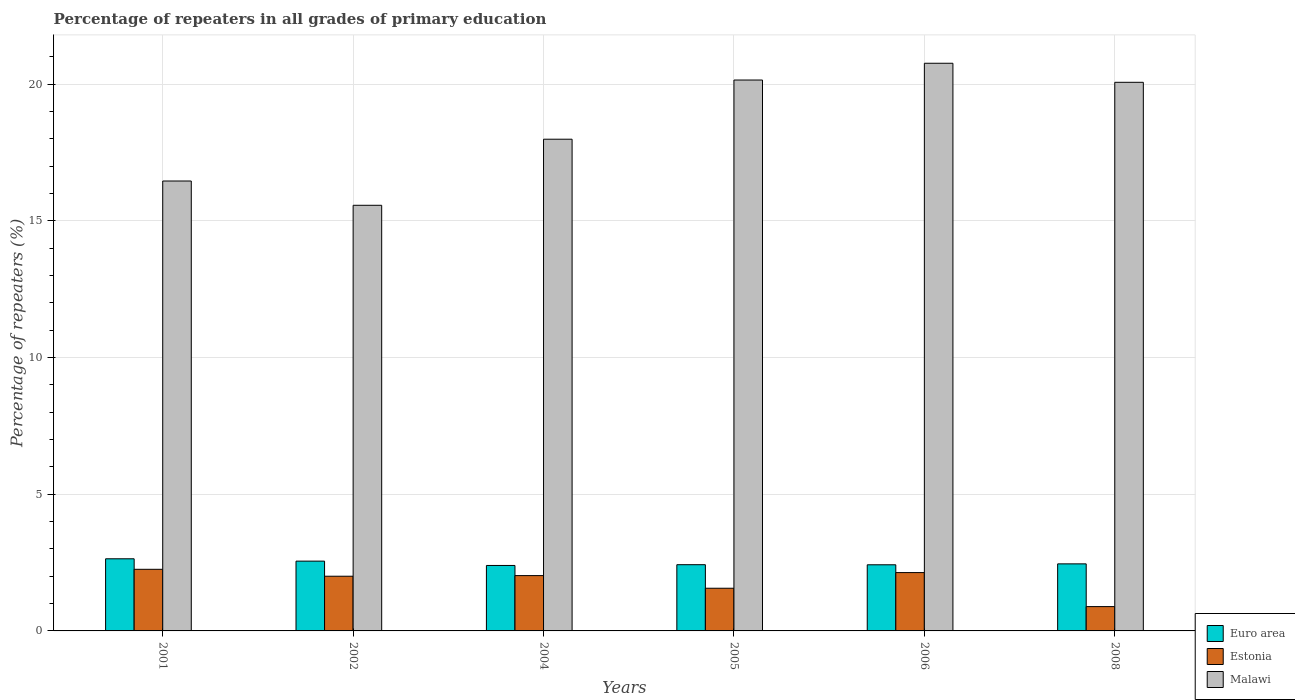How many different coloured bars are there?
Offer a terse response. 3. How many groups of bars are there?
Your answer should be compact. 6. Are the number of bars per tick equal to the number of legend labels?
Provide a succinct answer. Yes. Are the number of bars on each tick of the X-axis equal?
Your answer should be compact. Yes. How many bars are there on the 6th tick from the right?
Offer a very short reply. 3. What is the label of the 6th group of bars from the left?
Make the answer very short. 2008. What is the percentage of repeaters in Estonia in 2008?
Keep it short and to the point. 0.89. Across all years, what is the maximum percentage of repeaters in Estonia?
Your response must be concise. 2.25. Across all years, what is the minimum percentage of repeaters in Euro area?
Provide a short and direct response. 2.39. In which year was the percentage of repeaters in Estonia maximum?
Your answer should be very brief. 2001. What is the total percentage of repeaters in Malawi in the graph?
Provide a short and direct response. 111.03. What is the difference between the percentage of repeaters in Euro area in 2001 and that in 2008?
Offer a very short reply. 0.19. What is the difference between the percentage of repeaters in Estonia in 2008 and the percentage of repeaters in Euro area in 2004?
Ensure brevity in your answer.  -1.51. What is the average percentage of repeaters in Malawi per year?
Ensure brevity in your answer.  18.5. In the year 2002, what is the difference between the percentage of repeaters in Euro area and percentage of repeaters in Estonia?
Your answer should be very brief. 0.55. In how many years, is the percentage of repeaters in Estonia greater than 11 %?
Offer a terse response. 0. What is the ratio of the percentage of repeaters in Estonia in 2001 to that in 2006?
Give a very brief answer. 1.06. Is the percentage of repeaters in Malawi in 2001 less than that in 2004?
Provide a short and direct response. Yes. What is the difference between the highest and the second highest percentage of repeaters in Euro area?
Your answer should be very brief. 0.09. What is the difference between the highest and the lowest percentage of repeaters in Estonia?
Your answer should be compact. 1.36. In how many years, is the percentage of repeaters in Estonia greater than the average percentage of repeaters in Estonia taken over all years?
Provide a short and direct response. 4. Is the sum of the percentage of repeaters in Euro area in 2001 and 2005 greater than the maximum percentage of repeaters in Estonia across all years?
Your answer should be very brief. Yes. What does the 3rd bar from the left in 2006 represents?
Your answer should be very brief. Malawi. What does the 2nd bar from the right in 2008 represents?
Provide a short and direct response. Estonia. What is the difference between two consecutive major ticks on the Y-axis?
Your response must be concise. 5. How many legend labels are there?
Ensure brevity in your answer.  3. How are the legend labels stacked?
Your answer should be very brief. Vertical. What is the title of the graph?
Give a very brief answer. Percentage of repeaters in all grades of primary education. Does "Kazakhstan" appear as one of the legend labels in the graph?
Ensure brevity in your answer.  No. What is the label or title of the X-axis?
Provide a succinct answer. Years. What is the label or title of the Y-axis?
Offer a terse response. Percentage of repeaters (%). What is the Percentage of repeaters (%) in Euro area in 2001?
Make the answer very short. 2.64. What is the Percentage of repeaters (%) of Estonia in 2001?
Ensure brevity in your answer.  2.25. What is the Percentage of repeaters (%) in Malawi in 2001?
Provide a succinct answer. 16.46. What is the Percentage of repeaters (%) of Euro area in 2002?
Keep it short and to the point. 2.55. What is the Percentage of repeaters (%) in Estonia in 2002?
Make the answer very short. 2. What is the Percentage of repeaters (%) in Malawi in 2002?
Ensure brevity in your answer.  15.57. What is the Percentage of repeaters (%) in Euro area in 2004?
Provide a succinct answer. 2.39. What is the Percentage of repeaters (%) of Estonia in 2004?
Make the answer very short. 2.02. What is the Percentage of repeaters (%) in Malawi in 2004?
Provide a succinct answer. 17.99. What is the Percentage of repeaters (%) in Euro area in 2005?
Offer a very short reply. 2.42. What is the Percentage of repeaters (%) of Estonia in 2005?
Your answer should be very brief. 1.56. What is the Percentage of repeaters (%) of Malawi in 2005?
Your answer should be compact. 20.16. What is the Percentage of repeaters (%) of Euro area in 2006?
Offer a very short reply. 2.42. What is the Percentage of repeaters (%) in Estonia in 2006?
Provide a succinct answer. 2.13. What is the Percentage of repeaters (%) in Malawi in 2006?
Keep it short and to the point. 20.77. What is the Percentage of repeaters (%) in Euro area in 2008?
Your answer should be very brief. 2.45. What is the Percentage of repeaters (%) in Estonia in 2008?
Give a very brief answer. 0.89. What is the Percentage of repeaters (%) in Malawi in 2008?
Give a very brief answer. 20.07. Across all years, what is the maximum Percentage of repeaters (%) of Euro area?
Provide a short and direct response. 2.64. Across all years, what is the maximum Percentage of repeaters (%) of Estonia?
Your answer should be compact. 2.25. Across all years, what is the maximum Percentage of repeaters (%) of Malawi?
Offer a very short reply. 20.77. Across all years, what is the minimum Percentage of repeaters (%) in Euro area?
Offer a very short reply. 2.39. Across all years, what is the minimum Percentage of repeaters (%) of Estonia?
Make the answer very short. 0.89. Across all years, what is the minimum Percentage of repeaters (%) in Malawi?
Provide a succinct answer. 15.57. What is the total Percentage of repeaters (%) in Euro area in the graph?
Give a very brief answer. 14.88. What is the total Percentage of repeaters (%) in Estonia in the graph?
Give a very brief answer. 10.87. What is the total Percentage of repeaters (%) in Malawi in the graph?
Your answer should be compact. 111.03. What is the difference between the Percentage of repeaters (%) of Euro area in 2001 and that in 2002?
Offer a terse response. 0.09. What is the difference between the Percentage of repeaters (%) of Estonia in 2001 and that in 2002?
Offer a very short reply. 0.25. What is the difference between the Percentage of repeaters (%) in Malawi in 2001 and that in 2002?
Your answer should be very brief. 0.89. What is the difference between the Percentage of repeaters (%) in Euro area in 2001 and that in 2004?
Your answer should be compact. 0.24. What is the difference between the Percentage of repeaters (%) of Estonia in 2001 and that in 2004?
Offer a terse response. 0.23. What is the difference between the Percentage of repeaters (%) of Malawi in 2001 and that in 2004?
Offer a terse response. -1.53. What is the difference between the Percentage of repeaters (%) in Euro area in 2001 and that in 2005?
Keep it short and to the point. 0.22. What is the difference between the Percentage of repeaters (%) of Estonia in 2001 and that in 2005?
Make the answer very short. 0.69. What is the difference between the Percentage of repeaters (%) in Malawi in 2001 and that in 2005?
Your answer should be very brief. -3.69. What is the difference between the Percentage of repeaters (%) of Euro area in 2001 and that in 2006?
Ensure brevity in your answer.  0.22. What is the difference between the Percentage of repeaters (%) of Estonia in 2001 and that in 2006?
Make the answer very short. 0.12. What is the difference between the Percentage of repeaters (%) of Malawi in 2001 and that in 2006?
Provide a short and direct response. -4.31. What is the difference between the Percentage of repeaters (%) of Euro area in 2001 and that in 2008?
Your answer should be compact. 0.19. What is the difference between the Percentage of repeaters (%) in Estonia in 2001 and that in 2008?
Offer a very short reply. 1.36. What is the difference between the Percentage of repeaters (%) in Malawi in 2001 and that in 2008?
Ensure brevity in your answer.  -3.61. What is the difference between the Percentage of repeaters (%) of Euro area in 2002 and that in 2004?
Keep it short and to the point. 0.16. What is the difference between the Percentage of repeaters (%) of Estonia in 2002 and that in 2004?
Your answer should be very brief. -0.02. What is the difference between the Percentage of repeaters (%) in Malawi in 2002 and that in 2004?
Your answer should be compact. -2.42. What is the difference between the Percentage of repeaters (%) of Euro area in 2002 and that in 2005?
Offer a very short reply. 0.13. What is the difference between the Percentage of repeaters (%) of Estonia in 2002 and that in 2005?
Offer a very short reply. 0.44. What is the difference between the Percentage of repeaters (%) in Malawi in 2002 and that in 2005?
Your answer should be compact. -4.58. What is the difference between the Percentage of repeaters (%) in Euro area in 2002 and that in 2006?
Your answer should be compact. 0.13. What is the difference between the Percentage of repeaters (%) in Estonia in 2002 and that in 2006?
Make the answer very short. -0.13. What is the difference between the Percentage of repeaters (%) of Malawi in 2002 and that in 2006?
Offer a terse response. -5.2. What is the difference between the Percentage of repeaters (%) of Euro area in 2002 and that in 2008?
Offer a very short reply. 0.1. What is the difference between the Percentage of repeaters (%) in Estonia in 2002 and that in 2008?
Provide a short and direct response. 1.11. What is the difference between the Percentage of repeaters (%) of Malawi in 2002 and that in 2008?
Your response must be concise. -4.5. What is the difference between the Percentage of repeaters (%) of Euro area in 2004 and that in 2005?
Your response must be concise. -0.03. What is the difference between the Percentage of repeaters (%) of Estonia in 2004 and that in 2005?
Keep it short and to the point. 0.46. What is the difference between the Percentage of repeaters (%) of Malawi in 2004 and that in 2005?
Ensure brevity in your answer.  -2.17. What is the difference between the Percentage of repeaters (%) in Euro area in 2004 and that in 2006?
Your answer should be very brief. -0.02. What is the difference between the Percentage of repeaters (%) of Estonia in 2004 and that in 2006?
Offer a terse response. -0.11. What is the difference between the Percentage of repeaters (%) in Malawi in 2004 and that in 2006?
Your answer should be compact. -2.78. What is the difference between the Percentage of repeaters (%) of Euro area in 2004 and that in 2008?
Your response must be concise. -0.06. What is the difference between the Percentage of repeaters (%) in Estonia in 2004 and that in 2008?
Your answer should be compact. 1.13. What is the difference between the Percentage of repeaters (%) in Malawi in 2004 and that in 2008?
Offer a terse response. -2.08. What is the difference between the Percentage of repeaters (%) in Euro area in 2005 and that in 2006?
Offer a terse response. 0. What is the difference between the Percentage of repeaters (%) of Estonia in 2005 and that in 2006?
Give a very brief answer. -0.57. What is the difference between the Percentage of repeaters (%) of Malawi in 2005 and that in 2006?
Give a very brief answer. -0.61. What is the difference between the Percentage of repeaters (%) of Euro area in 2005 and that in 2008?
Provide a succinct answer. -0.03. What is the difference between the Percentage of repeaters (%) of Estonia in 2005 and that in 2008?
Your response must be concise. 0.67. What is the difference between the Percentage of repeaters (%) of Malawi in 2005 and that in 2008?
Your answer should be very brief. 0.08. What is the difference between the Percentage of repeaters (%) in Euro area in 2006 and that in 2008?
Your response must be concise. -0.03. What is the difference between the Percentage of repeaters (%) in Estonia in 2006 and that in 2008?
Provide a short and direct response. 1.25. What is the difference between the Percentage of repeaters (%) in Malawi in 2006 and that in 2008?
Make the answer very short. 0.7. What is the difference between the Percentage of repeaters (%) of Euro area in 2001 and the Percentage of repeaters (%) of Estonia in 2002?
Give a very brief answer. 0.64. What is the difference between the Percentage of repeaters (%) of Euro area in 2001 and the Percentage of repeaters (%) of Malawi in 2002?
Make the answer very short. -12.93. What is the difference between the Percentage of repeaters (%) in Estonia in 2001 and the Percentage of repeaters (%) in Malawi in 2002?
Ensure brevity in your answer.  -13.32. What is the difference between the Percentage of repeaters (%) in Euro area in 2001 and the Percentage of repeaters (%) in Estonia in 2004?
Give a very brief answer. 0.62. What is the difference between the Percentage of repeaters (%) of Euro area in 2001 and the Percentage of repeaters (%) of Malawi in 2004?
Provide a short and direct response. -15.35. What is the difference between the Percentage of repeaters (%) of Estonia in 2001 and the Percentage of repeaters (%) of Malawi in 2004?
Offer a very short reply. -15.74. What is the difference between the Percentage of repeaters (%) of Euro area in 2001 and the Percentage of repeaters (%) of Estonia in 2005?
Offer a terse response. 1.08. What is the difference between the Percentage of repeaters (%) of Euro area in 2001 and the Percentage of repeaters (%) of Malawi in 2005?
Your response must be concise. -17.52. What is the difference between the Percentage of repeaters (%) of Estonia in 2001 and the Percentage of repeaters (%) of Malawi in 2005?
Your answer should be compact. -17.9. What is the difference between the Percentage of repeaters (%) in Euro area in 2001 and the Percentage of repeaters (%) in Estonia in 2006?
Offer a terse response. 0.5. What is the difference between the Percentage of repeaters (%) of Euro area in 2001 and the Percentage of repeaters (%) of Malawi in 2006?
Your answer should be very brief. -18.13. What is the difference between the Percentage of repeaters (%) in Estonia in 2001 and the Percentage of repeaters (%) in Malawi in 2006?
Provide a succinct answer. -18.52. What is the difference between the Percentage of repeaters (%) of Euro area in 2001 and the Percentage of repeaters (%) of Estonia in 2008?
Your response must be concise. 1.75. What is the difference between the Percentage of repeaters (%) of Euro area in 2001 and the Percentage of repeaters (%) of Malawi in 2008?
Offer a very short reply. -17.43. What is the difference between the Percentage of repeaters (%) in Estonia in 2001 and the Percentage of repeaters (%) in Malawi in 2008?
Provide a short and direct response. -17.82. What is the difference between the Percentage of repeaters (%) of Euro area in 2002 and the Percentage of repeaters (%) of Estonia in 2004?
Your answer should be very brief. 0.53. What is the difference between the Percentage of repeaters (%) in Euro area in 2002 and the Percentage of repeaters (%) in Malawi in 2004?
Your answer should be very brief. -15.44. What is the difference between the Percentage of repeaters (%) in Estonia in 2002 and the Percentage of repeaters (%) in Malawi in 2004?
Ensure brevity in your answer.  -15.99. What is the difference between the Percentage of repeaters (%) in Euro area in 2002 and the Percentage of repeaters (%) in Malawi in 2005?
Your answer should be compact. -17.6. What is the difference between the Percentage of repeaters (%) of Estonia in 2002 and the Percentage of repeaters (%) of Malawi in 2005?
Offer a very short reply. -18.16. What is the difference between the Percentage of repeaters (%) of Euro area in 2002 and the Percentage of repeaters (%) of Estonia in 2006?
Provide a short and direct response. 0.42. What is the difference between the Percentage of repeaters (%) of Euro area in 2002 and the Percentage of repeaters (%) of Malawi in 2006?
Your response must be concise. -18.22. What is the difference between the Percentage of repeaters (%) in Estonia in 2002 and the Percentage of repeaters (%) in Malawi in 2006?
Your answer should be compact. -18.77. What is the difference between the Percentage of repeaters (%) of Euro area in 2002 and the Percentage of repeaters (%) of Estonia in 2008?
Your answer should be compact. 1.66. What is the difference between the Percentage of repeaters (%) in Euro area in 2002 and the Percentage of repeaters (%) in Malawi in 2008?
Offer a terse response. -17.52. What is the difference between the Percentage of repeaters (%) of Estonia in 2002 and the Percentage of repeaters (%) of Malawi in 2008?
Keep it short and to the point. -18.07. What is the difference between the Percentage of repeaters (%) of Euro area in 2004 and the Percentage of repeaters (%) of Estonia in 2005?
Make the answer very short. 0.83. What is the difference between the Percentage of repeaters (%) in Euro area in 2004 and the Percentage of repeaters (%) in Malawi in 2005?
Provide a short and direct response. -17.76. What is the difference between the Percentage of repeaters (%) in Estonia in 2004 and the Percentage of repeaters (%) in Malawi in 2005?
Give a very brief answer. -18.13. What is the difference between the Percentage of repeaters (%) in Euro area in 2004 and the Percentage of repeaters (%) in Estonia in 2006?
Keep it short and to the point. 0.26. What is the difference between the Percentage of repeaters (%) of Euro area in 2004 and the Percentage of repeaters (%) of Malawi in 2006?
Your response must be concise. -18.38. What is the difference between the Percentage of repeaters (%) in Estonia in 2004 and the Percentage of repeaters (%) in Malawi in 2006?
Your response must be concise. -18.75. What is the difference between the Percentage of repeaters (%) of Euro area in 2004 and the Percentage of repeaters (%) of Estonia in 2008?
Offer a very short reply. 1.51. What is the difference between the Percentage of repeaters (%) of Euro area in 2004 and the Percentage of repeaters (%) of Malawi in 2008?
Your answer should be compact. -17.68. What is the difference between the Percentage of repeaters (%) in Estonia in 2004 and the Percentage of repeaters (%) in Malawi in 2008?
Give a very brief answer. -18.05. What is the difference between the Percentage of repeaters (%) of Euro area in 2005 and the Percentage of repeaters (%) of Estonia in 2006?
Make the answer very short. 0.29. What is the difference between the Percentage of repeaters (%) in Euro area in 2005 and the Percentage of repeaters (%) in Malawi in 2006?
Provide a succinct answer. -18.35. What is the difference between the Percentage of repeaters (%) in Estonia in 2005 and the Percentage of repeaters (%) in Malawi in 2006?
Your answer should be very brief. -19.21. What is the difference between the Percentage of repeaters (%) of Euro area in 2005 and the Percentage of repeaters (%) of Estonia in 2008?
Provide a succinct answer. 1.53. What is the difference between the Percentage of repeaters (%) in Euro area in 2005 and the Percentage of repeaters (%) in Malawi in 2008?
Ensure brevity in your answer.  -17.65. What is the difference between the Percentage of repeaters (%) in Estonia in 2005 and the Percentage of repeaters (%) in Malawi in 2008?
Offer a terse response. -18.51. What is the difference between the Percentage of repeaters (%) in Euro area in 2006 and the Percentage of repeaters (%) in Estonia in 2008?
Your answer should be compact. 1.53. What is the difference between the Percentage of repeaters (%) of Euro area in 2006 and the Percentage of repeaters (%) of Malawi in 2008?
Make the answer very short. -17.65. What is the difference between the Percentage of repeaters (%) in Estonia in 2006 and the Percentage of repeaters (%) in Malawi in 2008?
Provide a succinct answer. -17.94. What is the average Percentage of repeaters (%) of Euro area per year?
Give a very brief answer. 2.48. What is the average Percentage of repeaters (%) of Estonia per year?
Make the answer very short. 1.81. What is the average Percentage of repeaters (%) of Malawi per year?
Ensure brevity in your answer.  18.5. In the year 2001, what is the difference between the Percentage of repeaters (%) of Euro area and Percentage of repeaters (%) of Estonia?
Offer a very short reply. 0.39. In the year 2001, what is the difference between the Percentage of repeaters (%) in Euro area and Percentage of repeaters (%) in Malawi?
Offer a terse response. -13.82. In the year 2001, what is the difference between the Percentage of repeaters (%) of Estonia and Percentage of repeaters (%) of Malawi?
Provide a short and direct response. -14.21. In the year 2002, what is the difference between the Percentage of repeaters (%) of Euro area and Percentage of repeaters (%) of Estonia?
Make the answer very short. 0.55. In the year 2002, what is the difference between the Percentage of repeaters (%) of Euro area and Percentage of repeaters (%) of Malawi?
Your response must be concise. -13.02. In the year 2002, what is the difference between the Percentage of repeaters (%) of Estonia and Percentage of repeaters (%) of Malawi?
Your response must be concise. -13.57. In the year 2004, what is the difference between the Percentage of repeaters (%) of Euro area and Percentage of repeaters (%) of Estonia?
Your response must be concise. 0.37. In the year 2004, what is the difference between the Percentage of repeaters (%) in Euro area and Percentage of repeaters (%) in Malawi?
Offer a very short reply. -15.6. In the year 2004, what is the difference between the Percentage of repeaters (%) in Estonia and Percentage of repeaters (%) in Malawi?
Your answer should be compact. -15.97. In the year 2005, what is the difference between the Percentage of repeaters (%) of Euro area and Percentage of repeaters (%) of Estonia?
Keep it short and to the point. 0.86. In the year 2005, what is the difference between the Percentage of repeaters (%) of Euro area and Percentage of repeaters (%) of Malawi?
Offer a terse response. -17.73. In the year 2005, what is the difference between the Percentage of repeaters (%) of Estonia and Percentage of repeaters (%) of Malawi?
Provide a short and direct response. -18.6. In the year 2006, what is the difference between the Percentage of repeaters (%) in Euro area and Percentage of repeaters (%) in Estonia?
Your answer should be very brief. 0.28. In the year 2006, what is the difference between the Percentage of repeaters (%) of Euro area and Percentage of repeaters (%) of Malawi?
Give a very brief answer. -18.35. In the year 2006, what is the difference between the Percentage of repeaters (%) in Estonia and Percentage of repeaters (%) in Malawi?
Provide a succinct answer. -18.64. In the year 2008, what is the difference between the Percentage of repeaters (%) in Euro area and Percentage of repeaters (%) in Estonia?
Provide a succinct answer. 1.56. In the year 2008, what is the difference between the Percentage of repeaters (%) of Euro area and Percentage of repeaters (%) of Malawi?
Keep it short and to the point. -17.62. In the year 2008, what is the difference between the Percentage of repeaters (%) of Estonia and Percentage of repeaters (%) of Malawi?
Ensure brevity in your answer.  -19.18. What is the ratio of the Percentage of repeaters (%) in Euro area in 2001 to that in 2002?
Give a very brief answer. 1.03. What is the ratio of the Percentage of repeaters (%) of Estonia in 2001 to that in 2002?
Provide a short and direct response. 1.13. What is the ratio of the Percentage of repeaters (%) of Malawi in 2001 to that in 2002?
Provide a short and direct response. 1.06. What is the ratio of the Percentage of repeaters (%) in Euro area in 2001 to that in 2004?
Keep it short and to the point. 1.1. What is the ratio of the Percentage of repeaters (%) of Estonia in 2001 to that in 2004?
Provide a short and direct response. 1.11. What is the ratio of the Percentage of repeaters (%) of Malawi in 2001 to that in 2004?
Provide a succinct answer. 0.92. What is the ratio of the Percentage of repeaters (%) in Euro area in 2001 to that in 2005?
Your answer should be very brief. 1.09. What is the ratio of the Percentage of repeaters (%) of Estonia in 2001 to that in 2005?
Give a very brief answer. 1.44. What is the ratio of the Percentage of repeaters (%) in Malawi in 2001 to that in 2005?
Your answer should be compact. 0.82. What is the ratio of the Percentage of repeaters (%) in Euro area in 2001 to that in 2006?
Provide a short and direct response. 1.09. What is the ratio of the Percentage of repeaters (%) in Estonia in 2001 to that in 2006?
Offer a terse response. 1.06. What is the ratio of the Percentage of repeaters (%) in Malawi in 2001 to that in 2006?
Provide a succinct answer. 0.79. What is the ratio of the Percentage of repeaters (%) of Euro area in 2001 to that in 2008?
Make the answer very short. 1.08. What is the ratio of the Percentage of repeaters (%) of Estonia in 2001 to that in 2008?
Provide a short and direct response. 2.53. What is the ratio of the Percentage of repeaters (%) in Malawi in 2001 to that in 2008?
Ensure brevity in your answer.  0.82. What is the ratio of the Percentage of repeaters (%) of Euro area in 2002 to that in 2004?
Ensure brevity in your answer.  1.07. What is the ratio of the Percentage of repeaters (%) of Estonia in 2002 to that in 2004?
Your answer should be compact. 0.99. What is the ratio of the Percentage of repeaters (%) in Malawi in 2002 to that in 2004?
Ensure brevity in your answer.  0.87. What is the ratio of the Percentage of repeaters (%) in Euro area in 2002 to that in 2005?
Your answer should be compact. 1.05. What is the ratio of the Percentage of repeaters (%) of Estonia in 2002 to that in 2005?
Offer a terse response. 1.28. What is the ratio of the Percentage of repeaters (%) of Malawi in 2002 to that in 2005?
Ensure brevity in your answer.  0.77. What is the ratio of the Percentage of repeaters (%) in Euro area in 2002 to that in 2006?
Provide a succinct answer. 1.06. What is the ratio of the Percentage of repeaters (%) of Estonia in 2002 to that in 2006?
Make the answer very short. 0.94. What is the ratio of the Percentage of repeaters (%) of Malawi in 2002 to that in 2006?
Make the answer very short. 0.75. What is the ratio of the Percentage of repeaters (%) of Euro area in 2002 to that in 2008?
Make the answer very short. 1.04. What is the ratio of the Percentage of repeaters (%) in Estonia in 2002 to that in 2008?
Offer a very short reply. 2.25. What is the ratio of the Percentage of repeaters (%) of Malawi in 2002 to that in 2008?
Your answer should be compact. 0.78. What is the ratio of the Percentage of repeaters (%) of Euro area in 2004 to that in 2005?
Offer a very short reply. 0.99. What is the ratio of the Percentage of repeaters (%) of Estonia in 2004 to that in 2005?
Offer a very short reply. 1.3. What is the ratio of the Percentage of repeaters (%) in Malawi in 2004 to that in 2005?
Your answer should be compact. 0.89. What is the ratio of the Percentage of repeaters (%) in Estonia in 2004 to that in 2006?
Offer a very short reply. 0.95. What is the ratio of the Percentage of repeaters (%) of Malawi in 2004 to that in 2006?
Your response must be concise. 0.87. What is the ratio of the Percentage of repeaters (%) of Euro area in 2004 to that in 2008?
Provide a succinct answer. 0.98. What is the ratio of the Percentage of repeaters (%) in Estonia in 2004 to that in 2008?
Your answer should be very brief. 2.27. What is the ratio of the Percentage of repeaters (%) of Malawi in 2004 to that in 2008?
Your response must be concise. 0.9. What is the ratio of the Percentage of repeaters (%) of Estonia in 2005 to that in 2006?
Give a very brief answer. 0.73. What is the ratio of the Percentage of repeaters (%) of Malawi in 2005 to that in 2006?
Your answer should be compact. 0.97. What is the ratio of the Percentage of repeaters (%) in Euro area in 2005 to that in 2008?
Your answer should be compact. 0.99. What is the ratio of the Percentage of repeaters (%) in Estonia in 2005 to that in 2008?
Offer a very short reply. 1.76. What is the ratio of the Percentage of repeaters (%) of Malawi in 2005 to that in 2008?
Offer a very short reply. 1. What is the ratio of the Percentage of repeaters (%) in Euro area in 2006 to that in 2008?
Make the answer very short. 0.99. What is the ratio of the Percentage of repeaters (%) in Estonia in 2006 to that in 2008?
Offer a very short reply. 2.4. What is the ratio of the Percentage of repeaters (%) in Malawi in 2006 to that in 2008?
Offer a terse response. 1.03. What is the difference between the highest and the second highest Percentage of repeaters (%) of Euro area?
Your response must be concise. 0.09. What is the difference between the highest and the second highest Percentage of repeaters (%) in Estonia?
Keep it short and to the point. 0.12. What is the difference between the highest and the second highest Percentage of repeaters (%) in Malawi?
Keep it short and to the point. 0.61. What is the difference between the highest and the lowest Percentage of repeaters (%) in Euro area?
Your answer should be very brief. 0.24. What is the difference between the highest and the lowest Percentage of repeaters (%) in Estonia?
Make the answer very short. 1.36. What is the difference between the highest and the lowest Percentage of repeaters (%) in Malawi?
Provide a succinct answer. 5.2. 